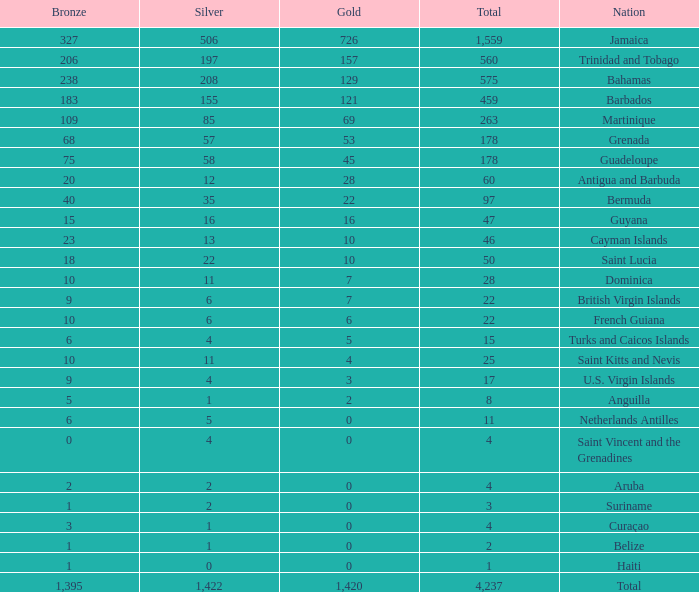What is listed as the highest Silver that also has a Gold of 4 and a Total that's larger than 25? None. 